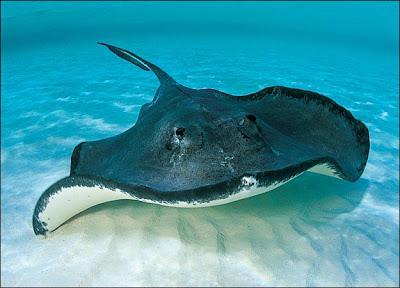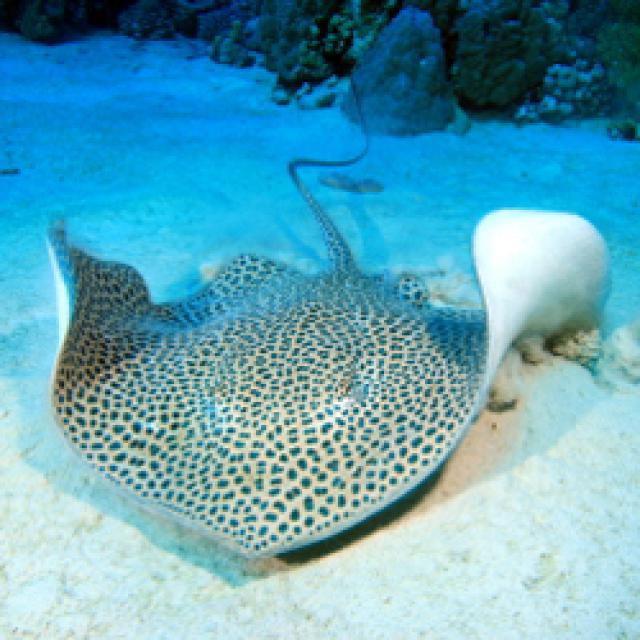The first image is the image on the left, the second image is the image on the right. Given the left and right images, does the statement "There are two stingrays and no other creatures." hold true? Answer yes or no. Yes. 